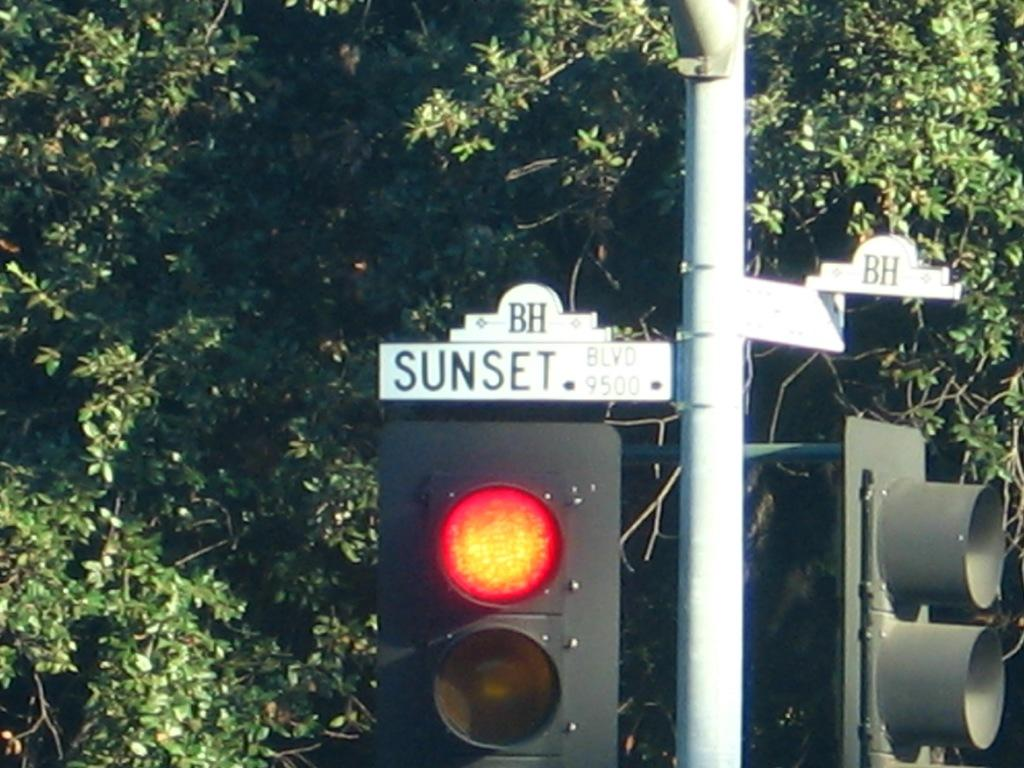What is the main object in the image? There is a pole with a signal light in the image. Can you describe the background of the image? There is a tree with leaves in the background of the image. What type of produce is being sold in the office in the image? There is no office or produce present in the image; it features a pole with a signal light and a tree with leaves in the background. 